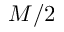<formula> <loc_0><loc_0><loc_500><loc_500>M / 2</formula> 